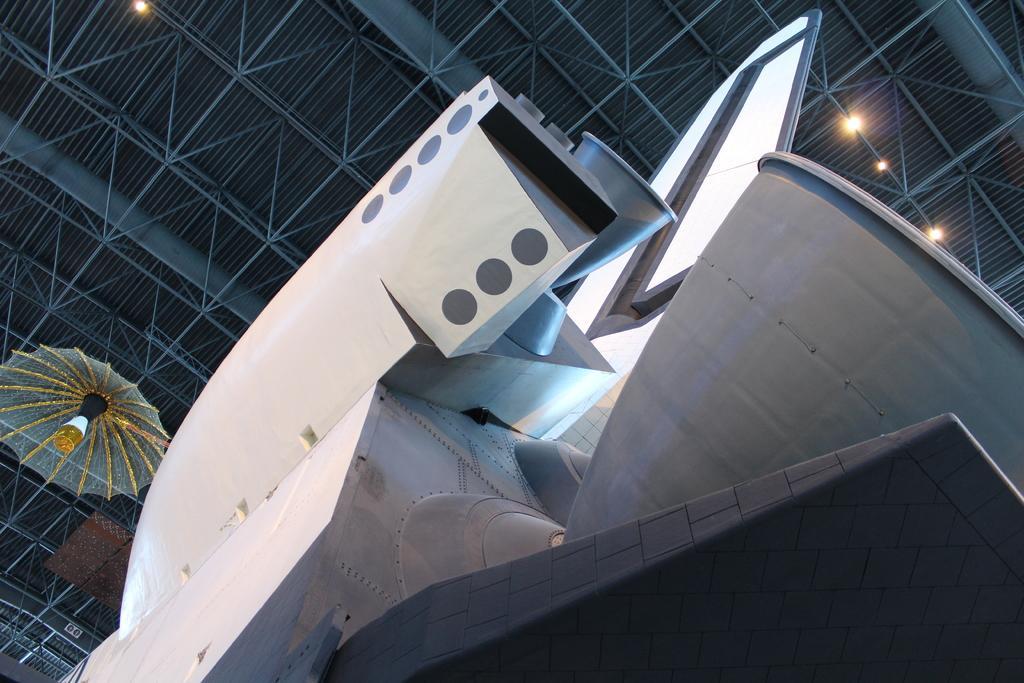How would you summarize this image in a sentence or two? In this image I can see a rocket which is white and grey in color. In the background I can see the ceiling, few lights to the ceiling and an object attached to the ceiling. 